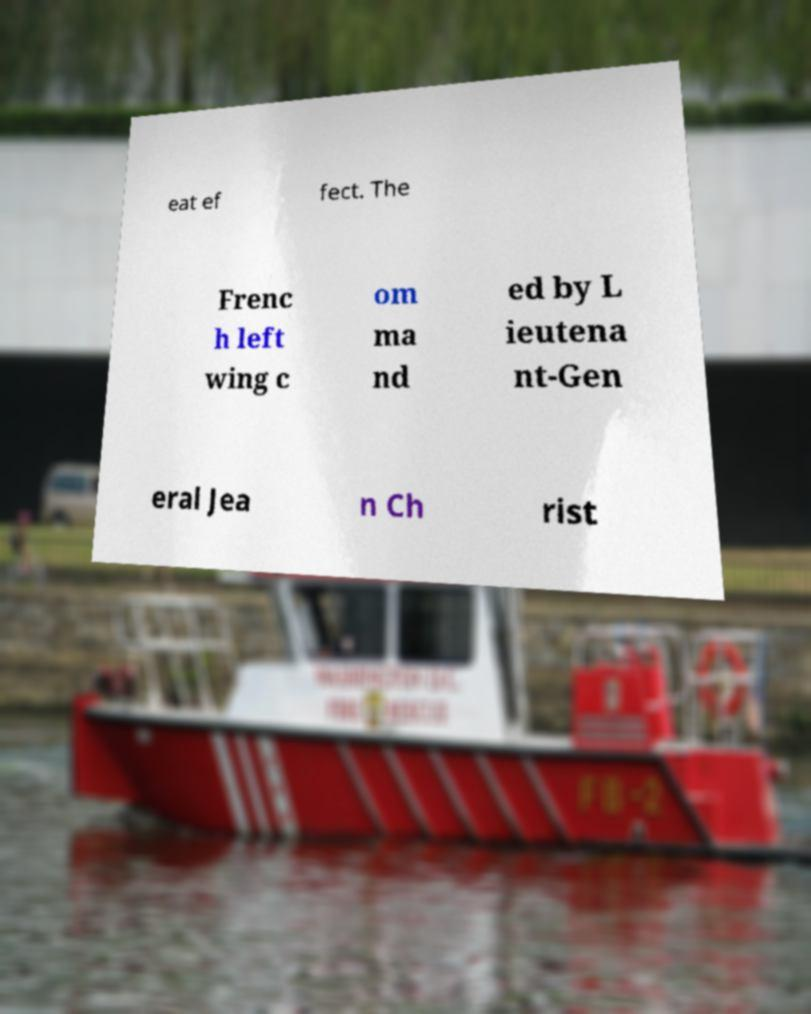Can you read and provide the text displayed in the image?This photo seems to have some interesting text. Can you extract and type it out for me? eat ef fect. The Frenc h left wing c om ma nd ed by L ieutena nt-Gen eral Jea n Ch rist 